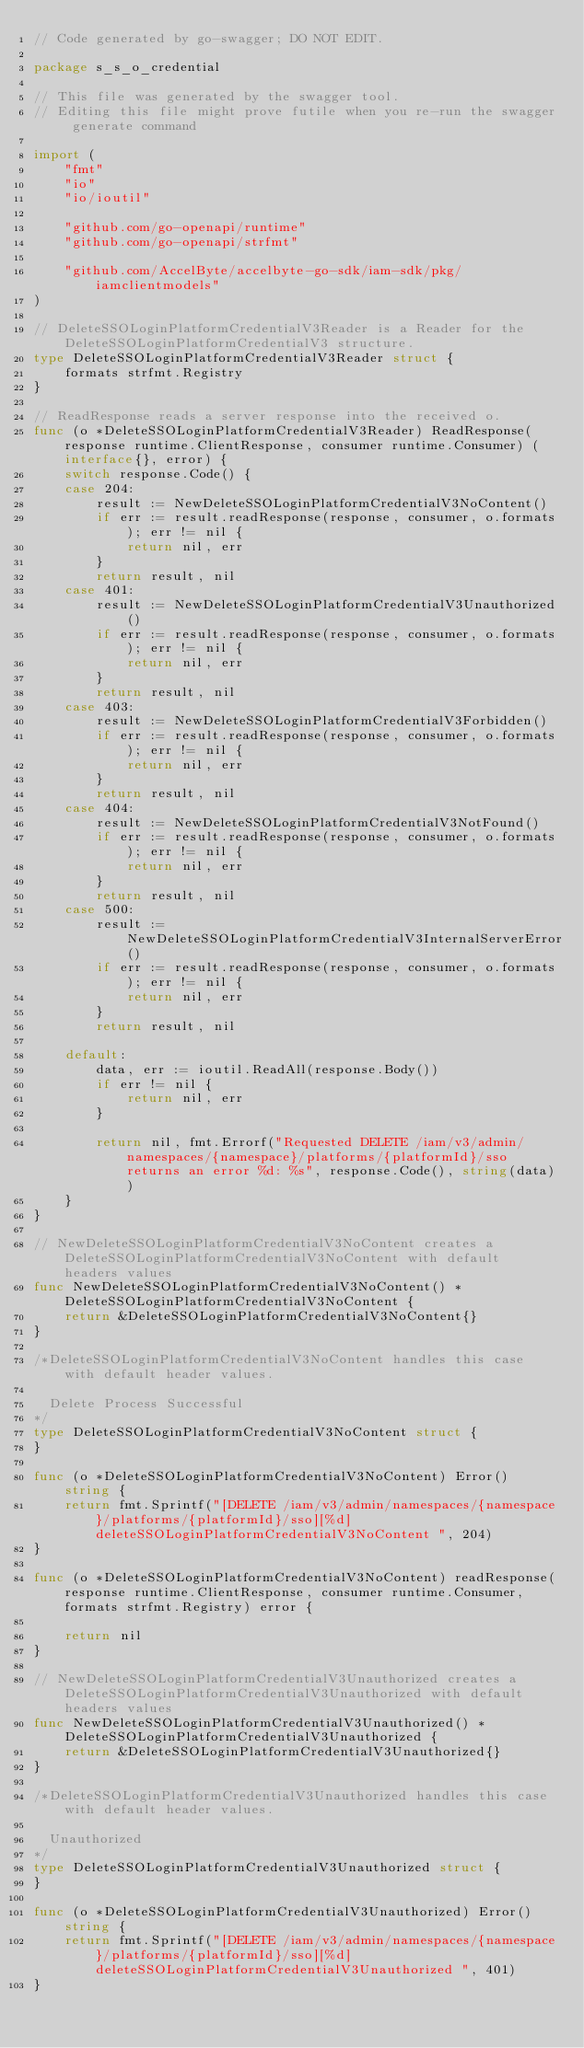<code> <loc_0><loc_0><loc_500><loc_500><_Go_>// Code generated by go-swagger; DO NOT EDIT.

package s_s_o_credential

// This file was generated by the swagger tool.
// Editing this file might prove futile when you re-run the swagger generate command

import (
	"fmt"
	"io"
	"io/ioutil"

	"github.com/go-openapi/runtime"
	"github.com/go-openapi/strfmt"

	"github.com/AccelByte/accelbyte-go-sdk/iam-sdk/pkg/iamclientmodels"
)

// DeleteSSOLoginPlatformCredentialV3Reader is a Reader for the DeleteSSOLoginPlatformCredentialV3 structure.
type DeleteSSOLoginPlatformCredentialV3Reader struct {
	formats strfmt.Registry
}

// ReadResponse reads a server response into the received o.
func (o *DeleteSSOLoginPlatformCredentialV3Reader) ReadResponse(response runtime.ClientResponse, consumer runtime.Consumer) (interface{}, error) {
	switch response.Code() {
	case 204:
		result := NewDeleteSSOLoginPlatformCredentialV3NoContent()
		if err := result.readResponse(response, consumer, o.formats); err != nil {
			return nil, err
		}
		return result, nil
	case 401:
		result := NewDeleteSSOLoginPlatformCredentialV3Unauthorized()
		if err := result.readResponse(response, consumer, o.formats); err != nil {
			return nil, err
		}
		return result, nil
	case 403:
		result := NewDeleteSSOLoginPlatformCredentialV3Forbidden()
		if err := result.readResponse(response, consumer, o.formats); err != nil {
			return nil, err
		}
		return result, nil
	case 404:
		result := NewDeleteSSOLoginPlatformCredentialV3NotFound()
		if err := result.readResponse(response, consumer, o.formats); err != nil {
			return nil, err
		}
		return result, nil
	case 500:
		result := NewDeleteSSOLoginPlatformCredentialV3InternalServerError()
		if err := result.readResponse(response, consumer, o.formats); err != nil {
			return nil, err
		}
		return result, nil

	default:
		data, err := ioutil.ReadAll(response.Body())
		if err != nil {
			return nil, err
		}

		return nil, fmt.Errorf("Requested DELETE /iam/v3/admin/namespaces/{namespace}/platforms/{platformId}/sso returns an error %d: %s", response.Code(), string(data))
	}
}

// NewDeleteSSOLoginPlatformCredentialV3NoContent creates a DeleteSSOLoginPlatformCredentialV3NoContent with default headers values
func NewDeleteSSOLoginPlatformCredentialV3NoContent() *DeleteSSOLoginPlatformCredentialV3NoContent {
	return &DeleteSSOLoginPlatformCredentialV3NoContent{}
}

/*DeleteSSOLoginPlatformCredentialV3NoContent handles this case with default header values.

  Delete Process Successful
*/
type DeleteSSOLoginPlatformCredentialV3NoContent struct {
}

func (o *DeleteSSOLoginPlatformCredentialV3NoContent) Error() string {
	return fmt.Sprintf("[DELETE /iam/v3/admin/namespaces/{namespace}/platforms/{platformId}/sso][%d] deleteSSOLoginPlatformCredentialV3NoContent ", 204)
}

func (o *DeleteSSOLoginPlatformCredentialV3NoContent) readResponse(response runtime.ClientResponse, consumer runtime.Consumer, formats strfmt.Registry) error {

	return nil
}

// NewDeleteSSOLoginPlatformCredentialV3Unauthorized creates a DeleteSSOLoginPlatformCredentialV3Unauthorized with default headers values
func NewDeleteSSOLoginPlatformCredentialV3Unauthorized() *DeleteSSOLoginPlatformCredentialV3Unauthorized {
	return &DeleteSSOLoginPlatformCredentialV3Unauthorized{}
}

/*DeleteSSOLoginPlatformCredentialV3Unauthorized handles this case with default header values.

  Unauthorized
*/
type DeleteSSOLoginPlatformCredentialV3Unauthorized struct {
}

func (o *DeleteSSOLoginPlatformCredentialV3Unauthorized) Error() string {
	return fmt.Sprintf("[DELETE /iam/v3/admin/namespaces/{namespace}/platforms/{platformId}/sso][%d] deleteSSOLoginPlatformCredentialV3Unauthorized ", 401)
}
</code> 